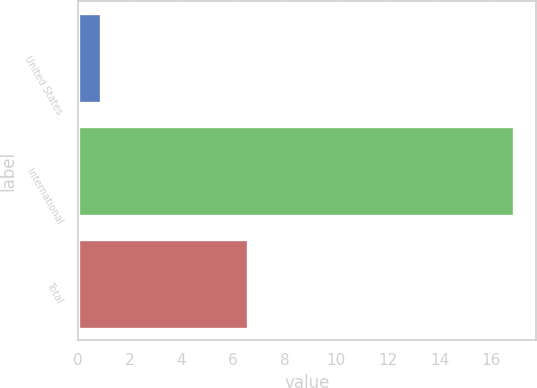<chart> <loc_0><loc_0><loc_500><loc_500><bar_chart><fcel>United States<fcel>International<fcel>Total<nl><fcel>0.9<fcel>16.9<fcel>6.6<nl></chart> 